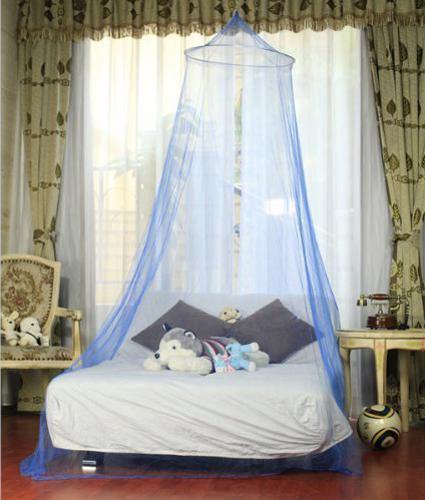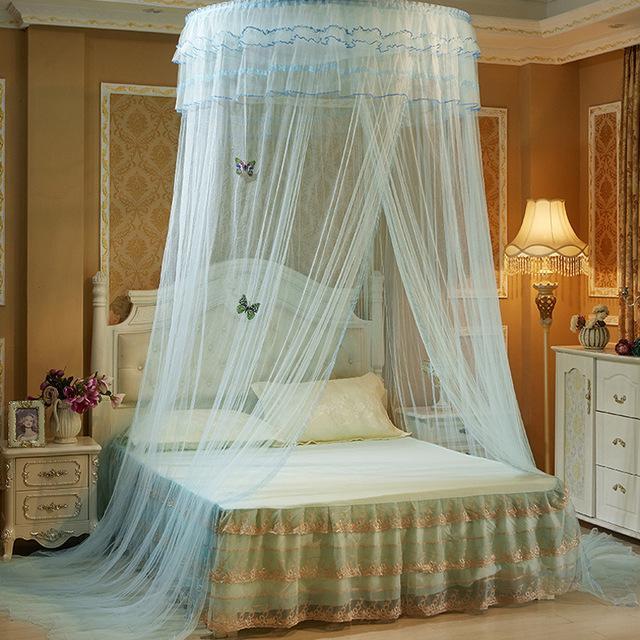The first image is the image on the left, the second image is the image on the right. Assess this claim about the two images: "Each image shows a gauzy canopy that drapes from a round shape suspended from the ceiling, and the right image features an aqua canopy with a ruffle around the top.". Correct or not? Answer yes or no. Yes. 